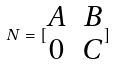<formula> <loc_0><loc_0><loc_500><loc_500>N = [ \begin{matrix} A & B \\ 0 & C \end{matrix} ]</formula> 